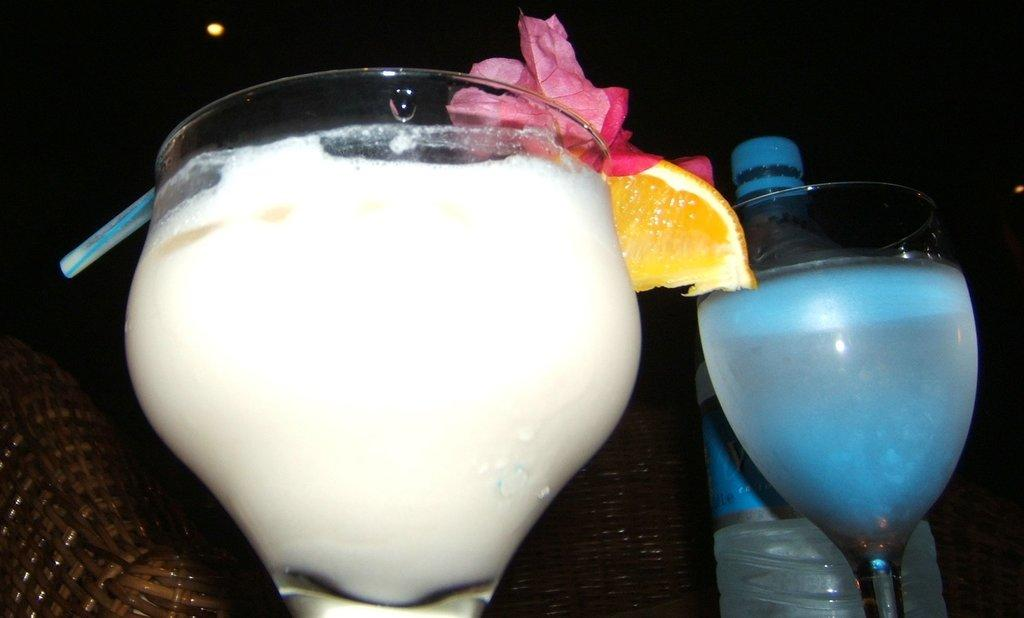What can be seen in the image related to beverages? There are two glasses with drinks in the image. What is located beside the glasses? There is a bottle beside the glasses. What type of object can be seen in the background of the image? There is a wooden object in the background of the image. How would you describe the lighting in the image? The background appears to be dark. What type of hat is being worn by the person in the image? There is no person present in the image, so it is not possible to determine if anyone is wearing a hat. 